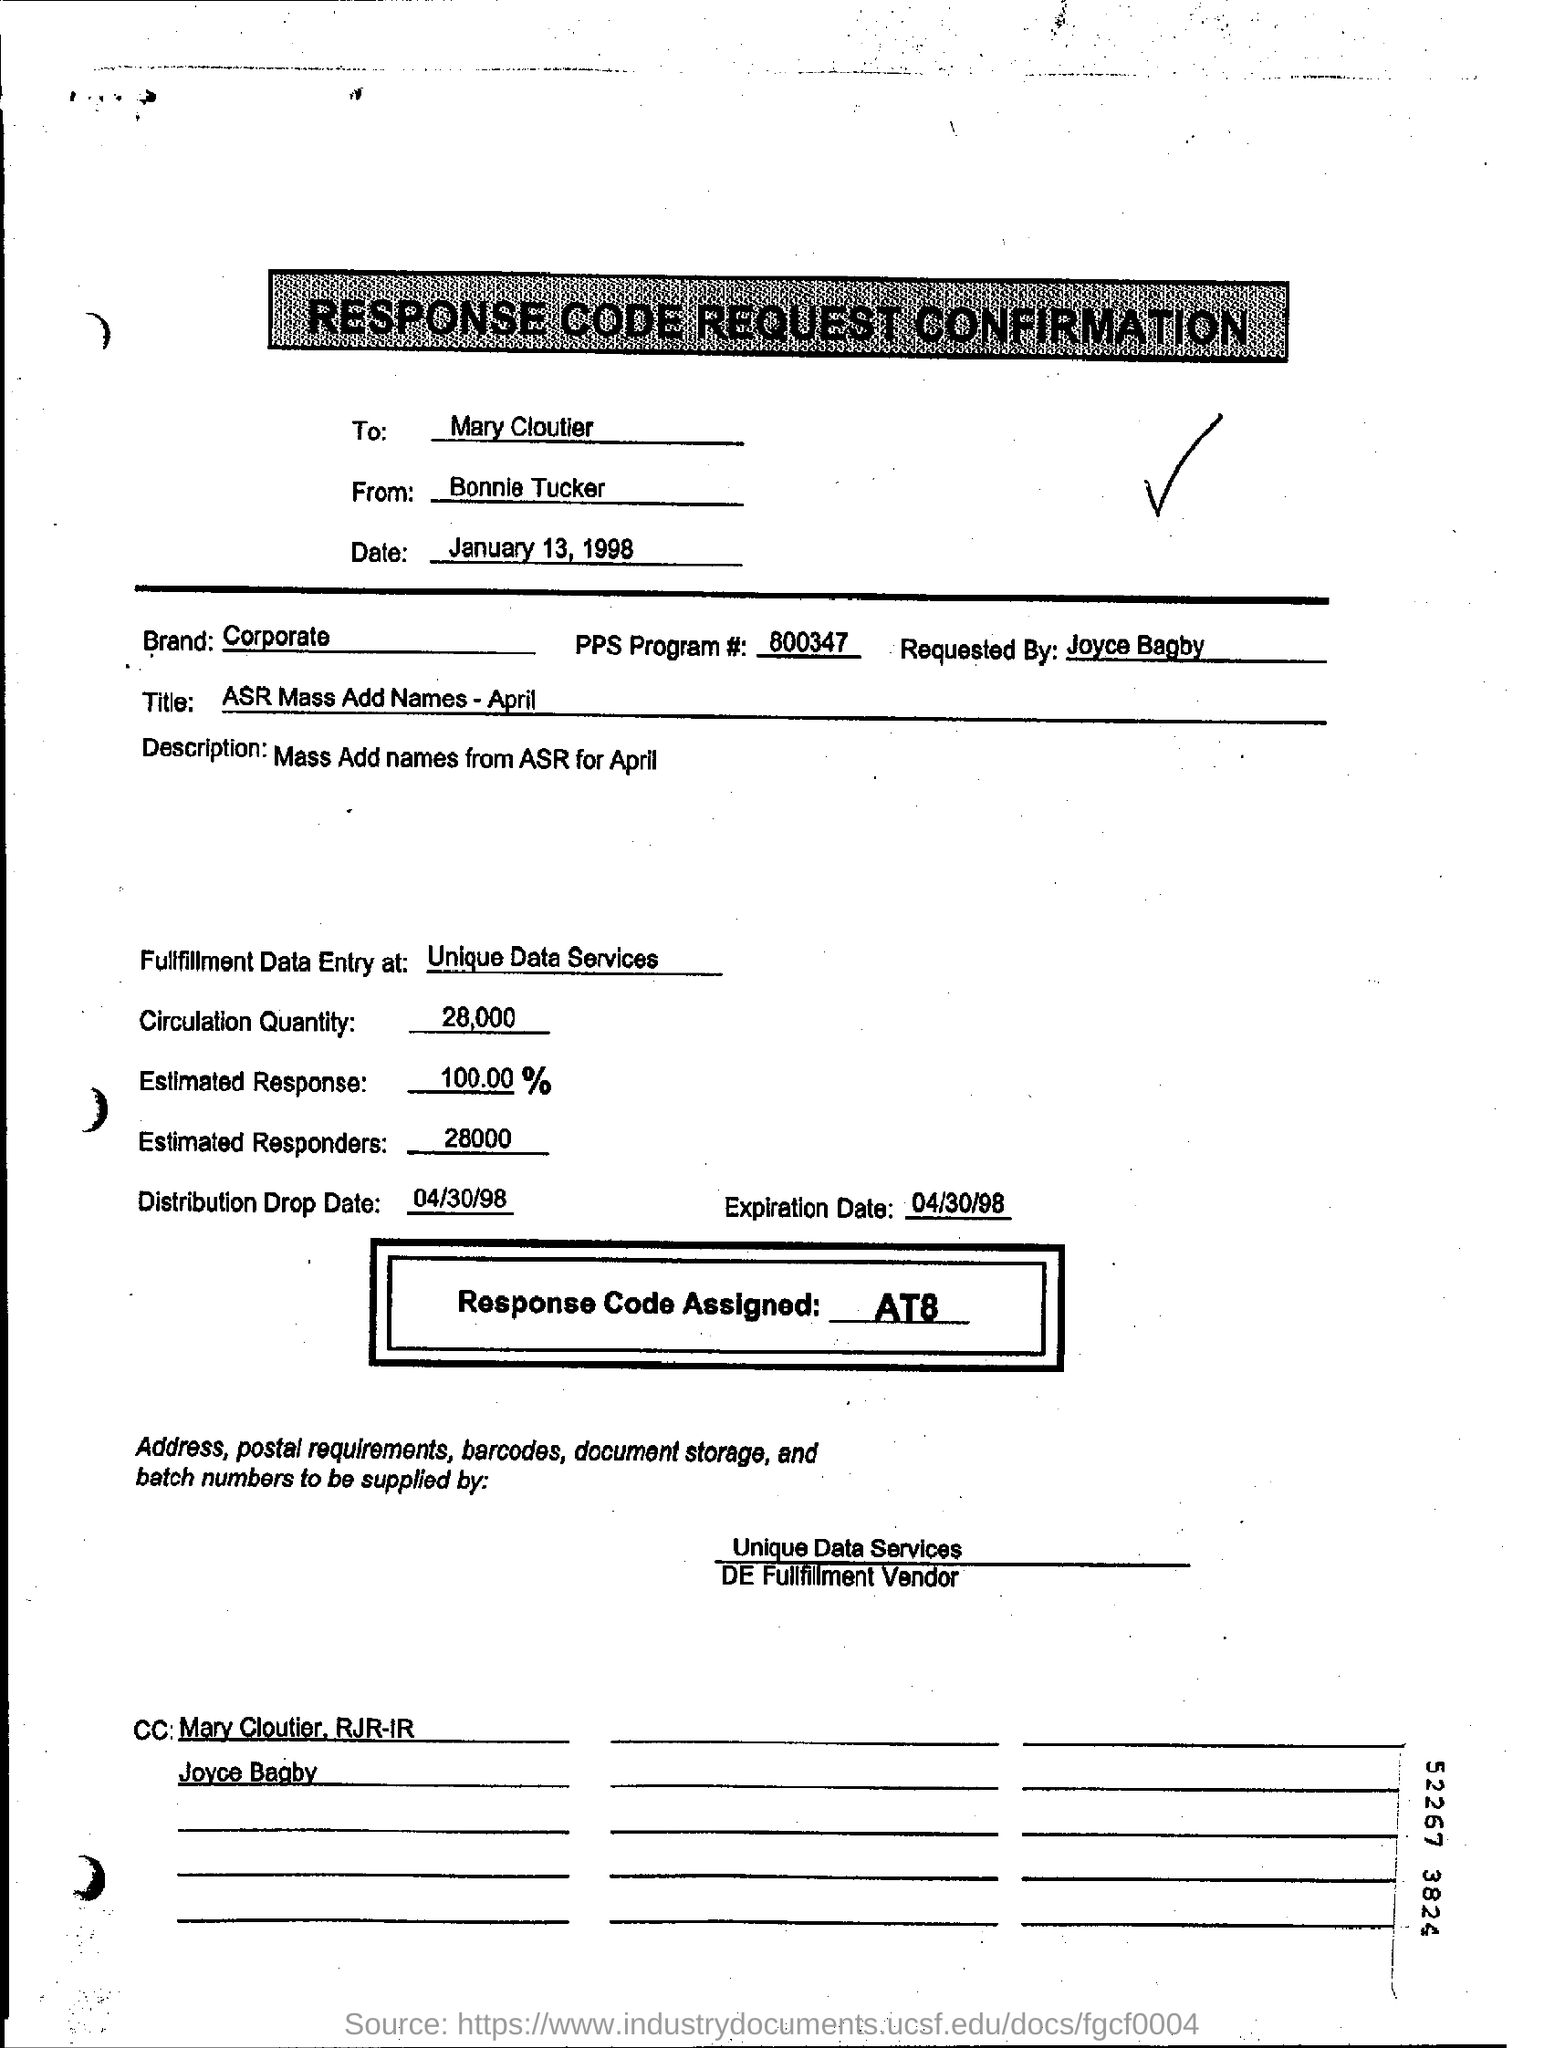How many responders are anticipated according to the document and why is this information important? According to the document, 28,000 responders are estimated, which represents a 100% response rate. This information is critical for planning and logistics purposes because it allows the organization to allocate the necessary resources, predict the impact of the distribution, and measure the success of the campaign. What might 'ASR Mass Add Names - April' refer to in this document? 'ASR Mass Add Names - April' likely refers to a corporate initiative taking place in April where a large number of names will be added to a system, database, or program. ASR might be an acronym for a specific process or department within the organization. The success of this initiative appears to be tracked through a response rate, which suggests it could involve some form of outreach or engagement. 